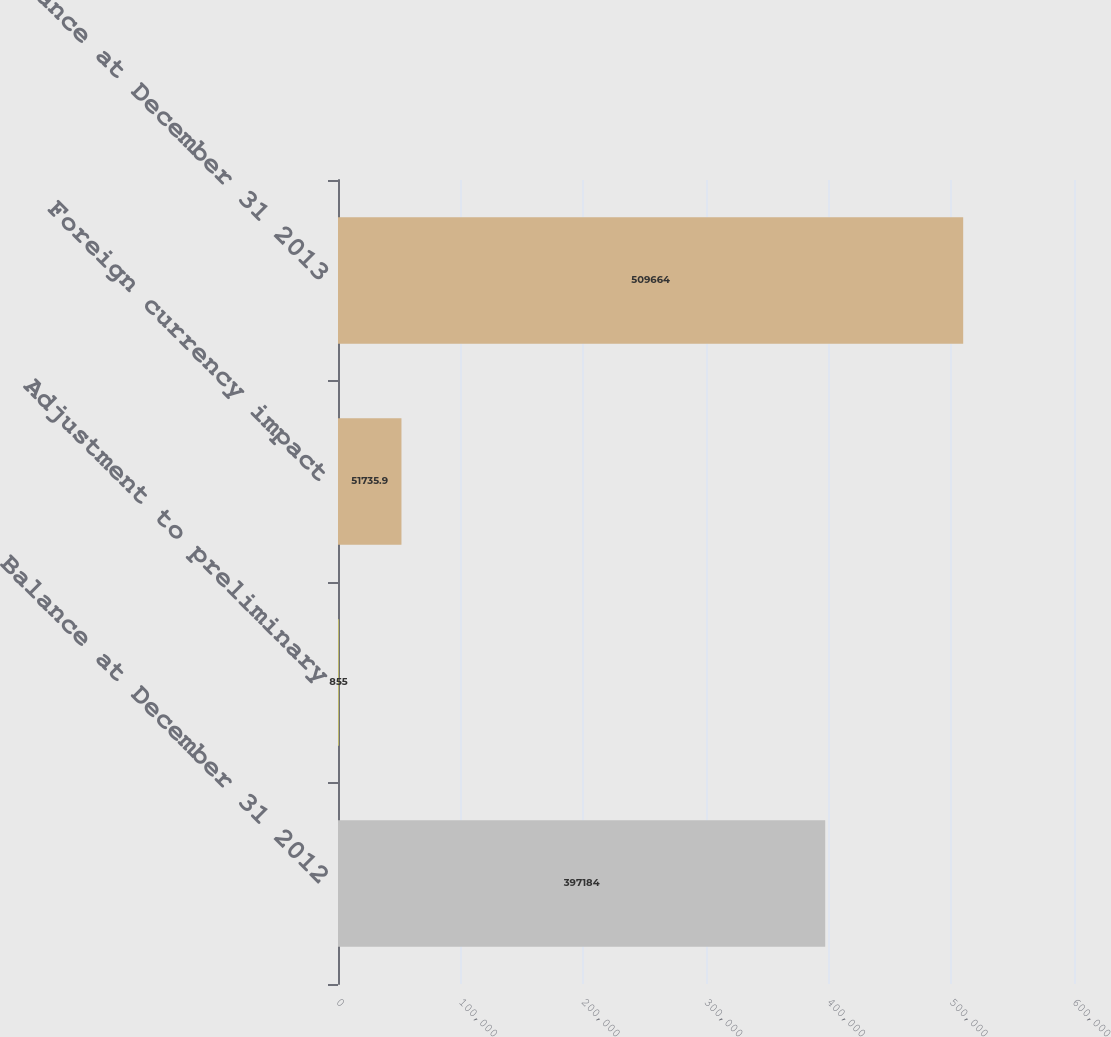Convert chart to OTSL. <chart><loc_0><loc_0><loc_500><loc_500><bar_chart><fcel>Balance at December 31 2012<fcel>Adjustment to preliminary<fcel>Foreign currency impact<fcel>Balance at December 31 2013<nl><fcel>397184<fcel>855<fcel>51735.9<fcel>509664<nl></chart> 